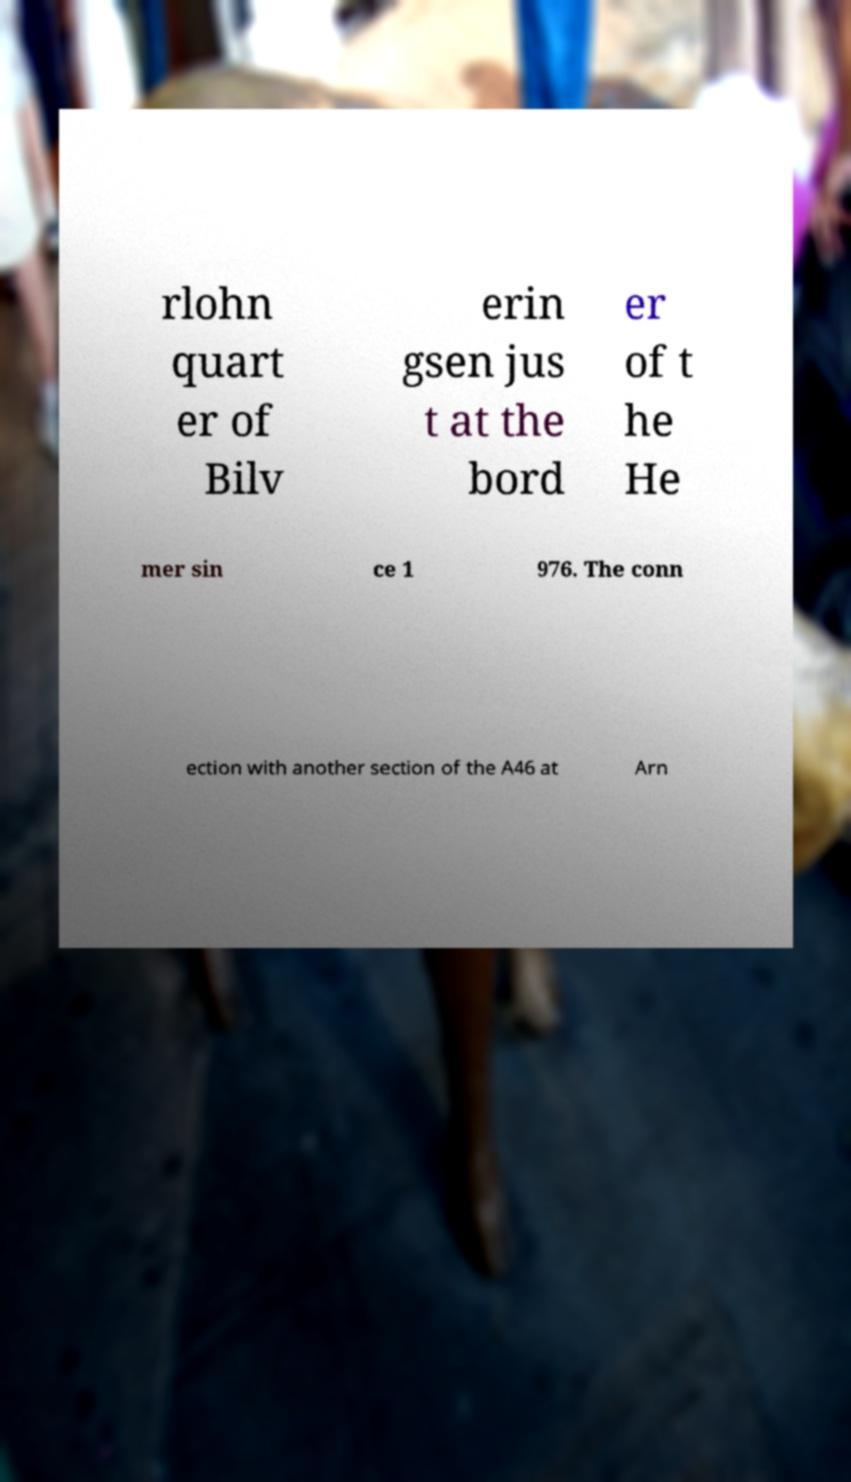Can you read and provide the text displayed in the image?This photo seems to have some interesting text. Can you extract and type it out for me? rlohn quart er of Bilv erin gsen jus t at the bord er of t he He mer sin ce 1 976. The conn ection with another section of the A46 at Arn 